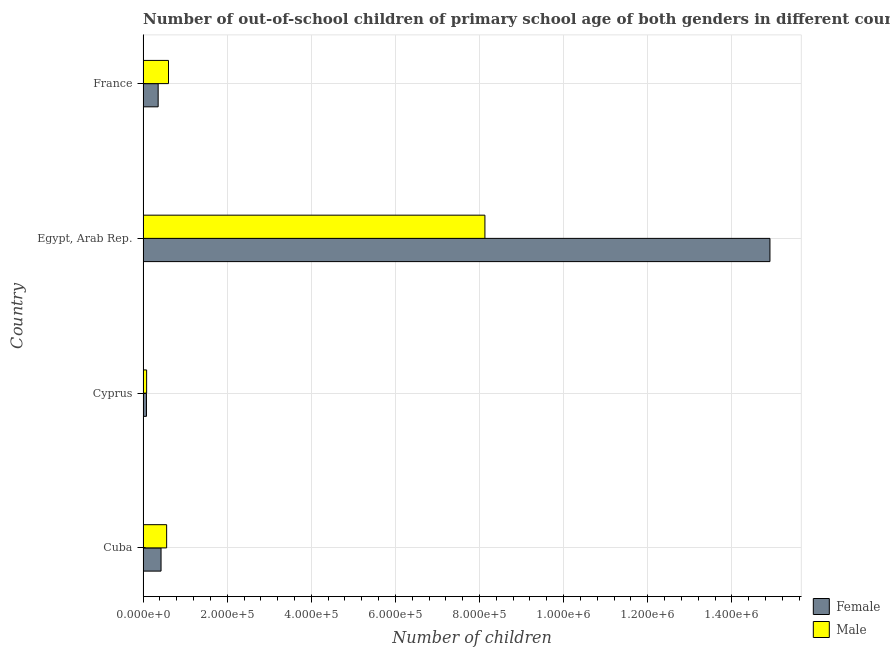How many different coloured bars are there?
Ensure brevity in your answer.  2. What is the label of the 1st group of bars from the top?
Give a very brief answer. France. What is the number of female out-of-school students in France?
Keep it short and to the point. 3.59e+04. Across all countries, what is the maximum number of male out-of-school students?
Your response must be concise. 8.13e+05. Across all countries, what is the minimum number of male out-of-school students?
Your answer should be very brief. 8466. In which country was the number of female out-of-school students maximum?
Offer a terse response. Egypt, Arab Rep. In which country was the number of male out-of-school students minimum?
Ensure brevity in your answer.  Cyprus. What is the total number of female out-of-school students in the graph?
Your answer should be compact. 1.58e+06. What is the difference between the number of male out-of-school students in Cyprus and that in Egypt, Arab Rep.?
Offer a terse response. -8.04e+05. What is the difference between the number of male out-of-school students in Cyprus and the number of female out-of-school students in Cuba?
Provide a short and direct response. -3.43e+04. What is the average number of female out-of-school students per country?
Your response must be concise. 3.94e+05. What is the difference between the number of male out-of-school students and number of female out-of-school students in Cuba?
Your response must be concise. 1.33e+04. What is the ratio of the number of male out-of-school students in Cyprus to that in Egypt, Arab Rep.?
Offer a very short reply. 0.01. Is the number of male out-of-school students in Cuba less than that in France?
Give a very brief answer. Yes. Is the difference between the number of female out-of-school students in Cuba and France greater than the difference between the number of male out-of-school students in Cuba and France?
Provide a succinct answer. Yes. What is the difference between the highest and the second highest number of male out-of-school students?
Keep it short and to the point. 7.52e+05. What is the difference between the highest and the lowest number of male out-of-school students?
Make the answer very short. 8.04e+05. In how many countries, is the number of male out-of-school students greater than the average number of male out-of-school students taken over all countries?
Offer a terse response. 1. Are all the bars in the graph horizontal?
Make the answer very short. Yes. Are the values on the major ticks of X-axis written in scientific E-notation?
Ensure brevity in your answer.  Yes. Does the graph contain any zero values?
Ensure brevity in your answer.  No. Where does the legend appear in the graph?
Offer a terse response. Bottom right. What is the title of the graph?
Offer a terse response. Number of out-of-school children of primary school age of both genders in different countries. Does "GDP per capita" appear as one of the legend labels in the graph?
Your response must be concise. No. What is the label or title of the X-axis?
Offer a terse response. Number of children. What is the label or title of the Y-axis?
Offer a very short reply. Country. What is the Number of children of Female in Cuba?
Offer a very short reply. 4.28e+04. What is the Number of children in Male in Cuba?
Make the answer very short. 5.61e+04. What is the Number of children in Female in Cyprus?
Your answer should be compact. 8085. What is the Number of children of Male in Cyprus?
Offer a very short reply. 8466. What is the Number of children in Female in Egypt, Arab Rep.?
Make the answer very short. 1.49e+06. What is the Number of children in Male in Egypt, Arab Rep.?
Give a very brief answer. 8.13e+05. What is the Number of children in Female in France?
Offer a very short reply. 3.59e+04. What is the Number of children in Male in France?
Offer a very short reply. 6.05e+04. Across all countries, what is the maximum Number of children in Female?
Make the answer very short. 1.49e+06. Across all countries, what is the maximum Number of children in Male?
Offer a terse response. 8.13e+05. Across all countries, what is the minimum Number of children in Female?
Make the answer very short. 8085. Across all countries, what is the minimum Number of children of Male?
Keep it short and to the point. 8466. What is the total Number of children of Female in the graph?
Make the answer very short. 1.58e+06. What is the total Number of children in Male in the graph?
Provide a short and direct response. 9.38e+05. What is the difference between the Number of children in Female in Cuba and that in Cyprus?
Make the answer very short. 3.47e+04. What is the difference between the Number of children in Male in Cuba and that in Cyprus?
Offer a terse response. 4.76e+04. What is the difference between the Number of children in Female in Cuba and that in Egypt, Arab Rep.?
Ensure brevity in your answer.  -1.45e+06. What is the difference between the Number of children in Male in Cuba and that in Egypt, Arab Rep.?
Offer a terse response. -7.57e+05. What is the difference between the Number of children of Female in Cuba and that in France?
Provide a short and direct response. 6855. What is the difference between the Number of children in Male in Cuba and that in France?
Keep it short and to the point. -4400. What is the difference between the Number of children of Female in Cyprus and that in Egypt, Arab Rep.?
Provide a short and direct response. -1.48e+06. What is the difference between the Number of children of Male in Cyprus and that in Egypt, Arab Rep.?
Make the answer very short. -8.04e+05. What is the difference between the Number of children in Female in Cyprus and that in France?
Make the answer very short. -2.78e+04. What is the difference between the Number of children of Male in Cyprus and that in France?
Your answer should be very brief. -5.20e+04. What is the difference between the Number of children in Female in Egypt, Arab Rep. and that in France?
Provide a short and direct response. 1.45e+06. What is the difference between the Number of children of Male in Egypt, Arab Rep. and that in France?
Offer a terse response. 7.52e+05. What is the difference between the Number of children in Female in Cuba and the Number of children in Male in Cyprus?
Give a very brief answer. 3.43e+04. What is the difference between the Number of children of Female in Cuba and the Number of children of Male in Egypt, Arab Rep.?
Give a very brief answer. -7.70e+05. What is the difference between the Number of children of Female in Cuba and the Number of children of Male in France?
Your answer should be compact. -1.77e+04. What is the difference between the Number of children in Female in Cyprus and the Number of children in Male in Egypt, Arab Rep.?
Offer a terse response. -8.05e+05. What is the difference between the Number of children in Female in Cyprus and the Number of children in Male in France?
Your response must be concise. -5.24e+04. What is the difference between the Number of children of Female in Egypt, Arab Rep. and the Number of children of Male in France?
Your answer should be very brief. 1.43e+06. What is the average Number of children in Female per country?
Your answer should be compact. 3.94e+05. What is the average Number of children in Male per country?
Your response must be concise. 2.34e+05. What is the difference between the Number of children of Female and Number of children of Male in Cuba?
Your answer should be compact. -1.33e+04. What is the difference between the Number of children in Female and Number of children in Male in Cyprus?
Offer a very short reply. -381. What is the difference between the Number of children in Female and Number of children in Male in Egypt, Arab Rep.?
Give a very brief answer. 6.78e+05. What is the difference between the Number of children of Female and Number of children of Male in France?
Provide a short and direct response. -2.46e+04. What is the ratio of the Number of children of Female in Cuba to that in Cyprus?
Provide a short and direct response. 5.29. What is the ratio of the Number of children of Male in Cuba to that in Cyprus?
Offer a terse response. 6.62. What is the ratio of the Number of children of Female in Cuba to that in Egypt, Arab Rep.?
Your response must be concise. 0.03. What is the ratio of the Number of children of Male in Cuba to that in Egypt, Arab Rep.?
Keep it short and to the point. 0.07. What is the ratio of the Number of children in Female in Cuba to that in France?
Your answer should be compact. 1.19. What is the ratio of the Number of children of Male in Cuba to that in France?
Offer a terse response. 0.93. What is the ratio of the Number of children of Female in Cyprus to that in Egypt, Arab Rep.?
Offer a terse response. 0.01. What is the ratio of the Number of children in Male in Cyprus to that in Egypt, Arab Rep.?
Provide a short and direct response. 0.01. What is the ratio of the Number of children in Female in Cyprus to that in France?
Offer a very short reply. 0.23. What is the ratio of the Number of children in Male in Cyprus to that in France?
Your response must be concise. 0.14. What is the ratio of the Number of children of Female in Egypt, Arab Rep. to that in France?
Offer a very short reply. 41.53. What is the ratio of the Number of children of Male in Egypt, Arab Rep. to that in France?
Keep it short and to the point. 13.44. What is the difference between the highest and the second highest Number of children in Female?
Offer a terse response. 1.45e+06. What is the difference between the highest and the second highest Number of children in Male?
Make the answer very short. 7.52e+05. What is the difference between the highest and the lowest Number of children in Female?
Your answer should be compact. 1.48e+06. What is the difference between the highest and the lowest Number of children in Male?
Your answer should be compact. 8.04e+05. 